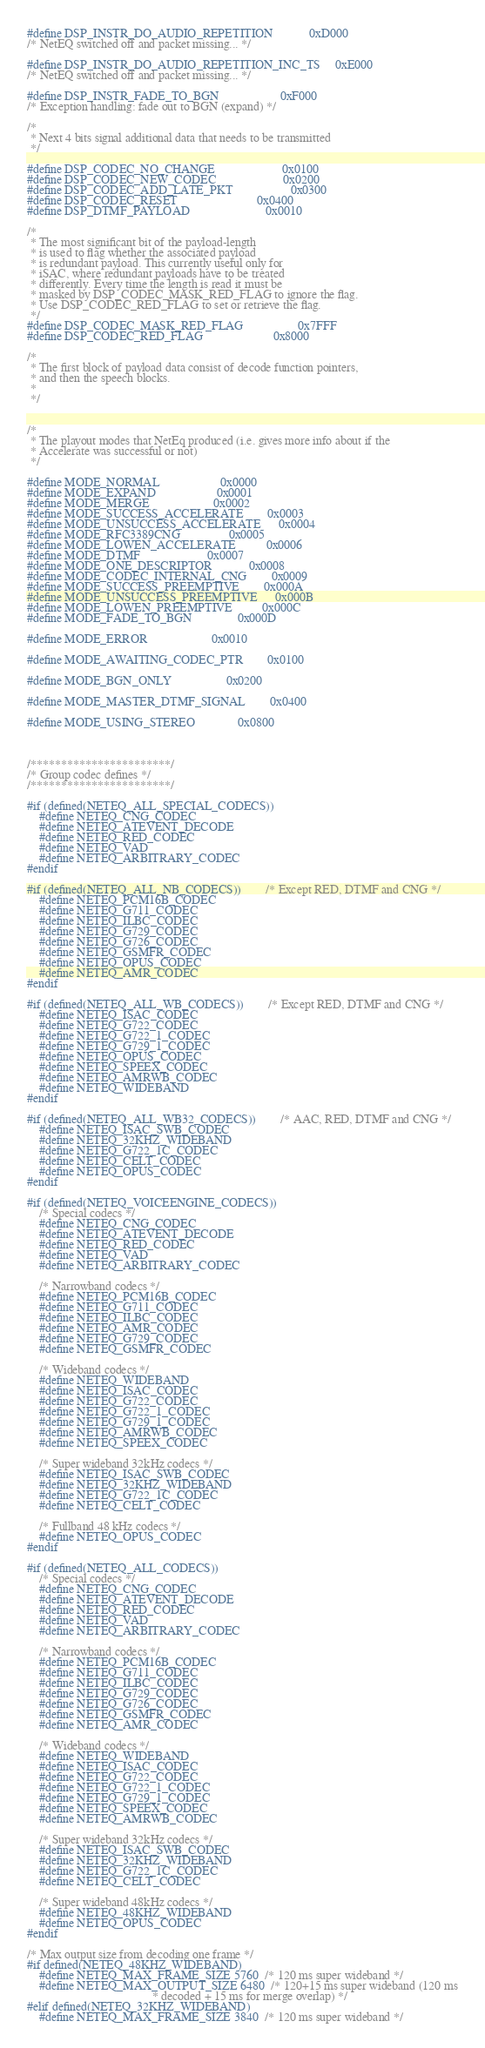Convert code to text. <code><loc_0><loc_0><loc_500><loc_500><_C_>#define DSP_INSTR_DO_AUDIO_REPETITION            0xD000
/* NetEQ switched off and packet missing... */

#define DSP_INSTR_DO_AUDIO_REPETITION_INC_TS     0xE000
/* NetEQ switched off and packet missing... */

#define DSP_INSTR_FADE_TO_BGN                    0xF000
/* Exception handling: fade out to BGN (expand) */

/*
 * Next 4 bits signal additional data that needs to be transmitted
 */

#define DSP_CODEC_NO_CHANGE                      0x0100
#define DSP_CODEC_NEW_CODEC                      0x0200
#define DSP_CODEC_ADD_LATE_PKT                   0x0300
#define DSP_CODEC_RESET                          0x0400
#define DSP_DTMF_PAYLOAD                         0x0010

/*
 * The most significant bit of the payload-length
 * is used to flag whether the associated payload
 * is redundant payload. This currently useful only for
 * iSAC, where redundant payloads have to be treated 
 * differently. Every time the length is read it must be
 * masked by DSP_CODEC_MASK_RED_FLAG to ignore the flag.
 * Use DSP_CODEC_RED_FLAG to set or retrieve the flag.
 */
#define DSP_CODEC_MASK_RED_FLAG                  0x7FFF
#define DSP_CODEC_RED_FLAG                       0x8000

/*
 * The first block of payload data consist of decode function pointers,
 * and then the speech blocks.
 *
 */


/*
 * The playout modes that NetEq produced (i.e. gives more info about if the 
 * Accelerate was successful or not)
 */

#define MODE_NORMAL                    0x0000
#define MODE_EXPAND                    0x0001
#define MODE_MERGE                     0x0002
#define MODE_SUCCESS_ACCELERATE        0x0003
#define MODE_UNSUCCESS_ACCELERATE      0x0004
#define MODE_RFC3389CNG                0x0005
#define MODE_LOWEN_ACCELERATE          0x0006
#define MODE_DTMF                      0x0007
#define MODE_ONE_DESCRIPTOR            0x0008
#define MODE_CODEC_INTERNAL_CNG        0x0009
#define MODE_SUCCESS_PREEMPTIVE        0x000A
#define MODE_UNSUCCESS_PREEMPTIVE      0x000B
#define MODE_LOWEN_PREEMPTIVE          0x000C
#define MODE_FADE_TO_BGN               0x000D

#define MODE_ERROR                     0x0010

#define MODE_AWAITING_CODEC_PTR        0x0100

#define MODE_BGN_ONLY                  0x0200

#define MODE_MASTER_DTMF_SIGNAL        0x0400

#define MODE_USING_STEREO              0x0800



/***********************/
/* Group codec defines */
/***********************/

#if (defined(NETEQ_ALL_SPECIAL_CODECS))
    #define NETEQ_CNG_CODEC
    #define NETEQ_ATEVENT_DECODE
    #define NETEQ_RED_CODEC
    #define NETEQ_VAD
    #define NETEQ_ARBITRARY_CODEC
#endif

#if (defined(NETEQ_ALL_NB_CODECS))        /* Except RED, DTMF and CNG */
    #define NETEQ_PCM16B_CODEC
    #define NETEQ_G711_CODEC
    #define NETEQ_ILBC_CODEC
    #define NETEQ_G729_CODEC
    #define NETEQ_G726_CODEC
    #define NETEQ_GSMFR_CODEC
    #define NETEQ_OPUS_CODEC
    #define NETEQ_AMR_CODEC
#endif

#if (defined(NETEQ_ALL_WB_CODECS))        /* Except RED, DTMF and CNG */
    #define NETEQ_ISAC_CODEC
    #define NETEQ_G722_CODEC
    #define NETEQ_G722_1_CODEC
    #define NETEQ_G729_1_CODEC
    #define NETEQ_OPUS_CODEC
    #define NETEQ_SPEEX_CODEC
    #define NETEQ_AMRWB_CODEC
    #define NETEQ_WIDEBAND
#endif

#if (defined(NETEQ_ALL_WB32_CODECS))        /* AAC, RED, DTMF and CNG */
    #define NETEQ_ISAC_SWB_CODEC
    #define NETEQ_32KHZ_WIDEBAND
    #define NETEQ_G722_1C_CODEC
    #define NETEQ_CELT_CODEC
    #define NETEQ_OPUS_CODEC
#endif

#if (defined(NETEQ_VOICEENGINE_CODECS))
    /* Special codecs */
    #define NETEQ_CNG_CODEC
    #define NETEQ_ATEVENT_DECODE
    #define NETEQ_RED_CODEC
    #define NETEQ_VAD
    #define NETEQ_ARBITRARY_CODEC

    /* Narrowband codecs */
    #define NETEQ_PCM16B_CODEC
    #define NETEQ_G711_CODEC
    #define NETEQ_ILBC_CODEC
    #define NETEQ_AMR_CODEC
    #define NETEQ_G729_CODEC
    #define NETEQ_GSMFR_CODEC

    /* Wideband codecs */
    #define NETEQ_WIDEBAND
    #define NETEQ_ISAC_CODEC
    #define NETEQ_G722_CODEC
    #define NETEQ_G722_1_CODEC
    #define NETEQ_G729_1_CODEC
    #define NETEQ_AMRWB_CODEC
    #define NETEQ_SPEEX_CODEC

    /* Super wideband 32kHz codecs */
    #define NETEQ_ISAC_SWB_CODEC
    #define NETEQ_32KHZ_WIDEBAND
    #define NETEQ_G722_1C_CODEC
    #define NETEQ_CELT_CODEC

    /* Fullband 48 kHz codecs */
    #define NETEQ_OPUS_CODEC
#endif 

#if (defined(NETEQ_ALL_CODECS))
    /* Special codecs */
    #define NETEQ_CNG_CODEC
    #define NETEQ_ATEVENT_DECODE
    #define NETEQ_RED_CODEC
    #define NETEQ_VAD
    #define NETEQ_ARBITRARY_CODEC

    /* Narrowband codecs */
    #define NETEQ_PCM16B_CODEC
    #define NETEQ_G711_CODEC
    #define NETEQ_ILBC_CODEC
    #define NETEQ_G729_CODEC
    #define NETEQ_G726_CODEC
    #define NETEQ_GSMFR_CODEC
    #define NETEQ_AMR_CODEC

    /* Wideband codecs */
    #define NETEQ_WIDEBAND
    #define NETEQ_ISAC_CODEC
    #define NETEQ_G722_CODEC
    #define NETEQ_G722_1_CODEC
    #define NETEQ_G729_1_CODEC
    #define NETEQ_SPEEX_CODEC
    #define NETEQ_AMRWB_CODEC

    /* Super wideband 32kHz codecs */
    #define NETEQ_ISAC_SWB_CODEC
    #define NETEQ_32KHZ_WIDEBAND
    #define NETEQ_G722_1C_CODEC
    #define NETEQ_CELT_CODEC

    /* Super wideband 48kHz codecs */
    #define NETEQ_48KHZ_WIDEBAND
    #define NETEQ_OPUS_CODEC
#endif

/* Max output size from decoding one frame */
#if defined(NETEQ_48KHZ_WIDEBAND)
    #define NETEQ_MAX_FRAME_SIZE 5760  /* 120 ms super wideband */
    #define NETEQ_MAX_OUTPUT_SIZE 6480  /* 120+15 ms super wideband (120 ms
                                         * decoded + 15 ms for merge overlap) */
#elif defined(NETEQ_32KHZ_WIDEBAND)
    #define NETEQ_MAX_FRAME_SIZE 3840  /* 120 ms super wideband */</code> 